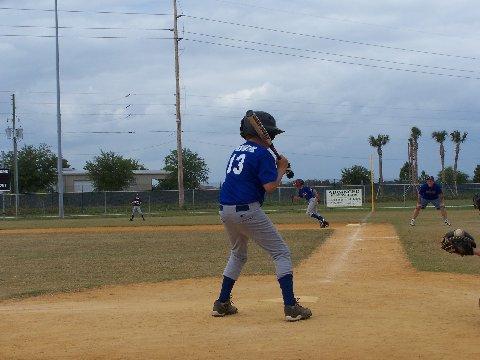What sport is this?
Write a very short answer. Baseball. What is the batter's number?
Keep it brief. 13. What number is the batter?
Keep it brief. 13. Where are the kids playing?
Give a very brief answer. Baseball field. What sport are these people playing?
Concise answer only. Baseball. What kind of trees are behind first base?
Be succinct. Palm. Is this a motorcycle race?
Keep it brief. No. What surface are they playing atop?
Answer briefly. Baseball field. Is he still holding the bat?
Answer briefly. Yes. What sport is this man playing?
Write a very short answer. Baseball. What number is the person batting?
Answer briefly. 13. What sport are the children playing?
Concise answer only. Baseball. Could this be soccer practice?
Keep it brief. No. 